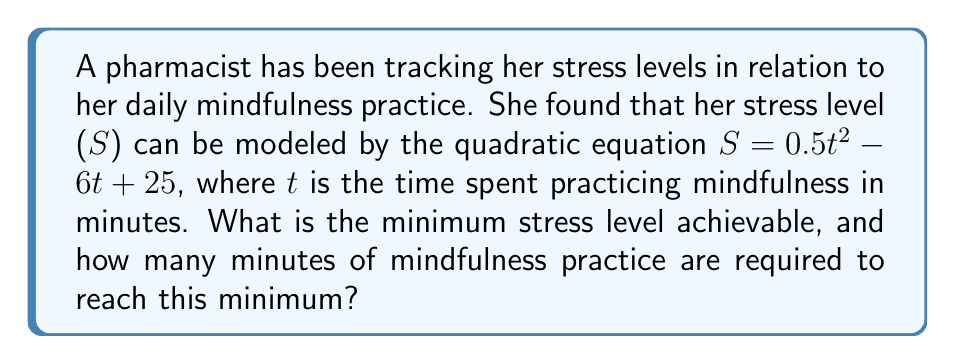Could you help me with this problem? To solve this problem, we need to follow these steps:

1) The given quadratic equation is in the form $S = 0.5t^2 - 6t + 25$, which can be written as $S = a(t^2) + b(t) + c$, where $a = 0.5$, $b = -6$, and $c = 25$.

2) For a quadratic function, the minimum (or maximum) point occurs at the vertex of the parabola. The t-coordinate of the vertex can be found using the formula: $t = -\frac{b}{2a}$

3) Let's calculate the t-coordinate:
   $t = -\frac{(-6)}{2(0.5)} = -\frac{-6}{1} = 6$

4) This means that the minimum stress level occurs when the pharmacist practices mindfulness for 6 minutes.

5) To find the minimum stress level, we substitute $t = 6$ into the original equation:

   $S = 0.5(6^2) - 6(6) + 25$
   $= 0.5(36) - 36 + 25$
   $= 18 - 36 + 25$
   $= 7$

Therefore, the minimum stress level is 7, achieved after 6 minutes of mindfulness practice.
Answer: The minimum stress level achievable is 7, and it requires 6 minutes of mindfulness practice. 